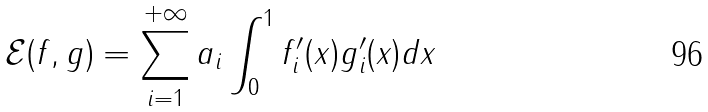Convert formula to latex. <formula><loc_0><loc_0><loc_500><loc_500>\mathcal { E } ( f , g ) = \sum _ { i = 1 } ^ { + \infty } a _ { i } \int _ { 0 } ^ { 1 } f ^ { \prime } _ { i } ( x ) g _ { i } ^ { \prime } ( x ) d x</formula> 